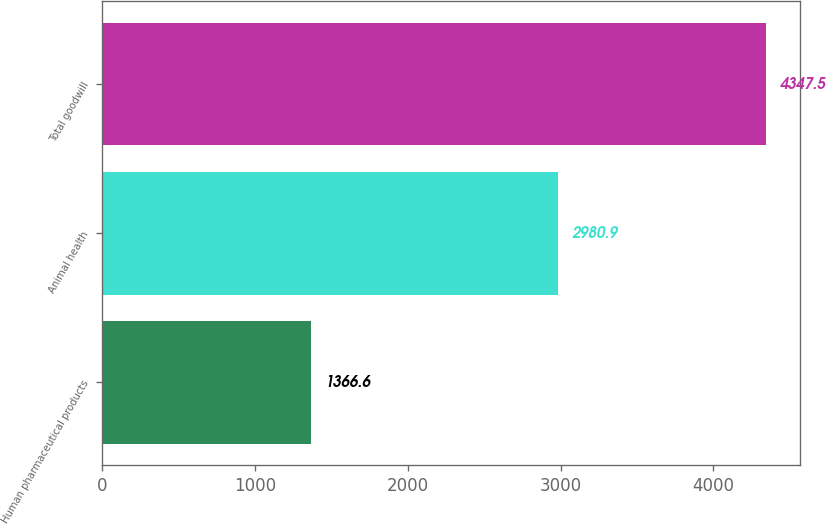Convert chart. <chart><loc_0><loc_0><loc_500><loc_500><bar_chart><fcel>Human pharmaceutical products<fcel>Animal health<fcel>Total goodwill<nl><fcel>1366.6<fcel>2980.9<fcel>4347.5<nl></chart> 